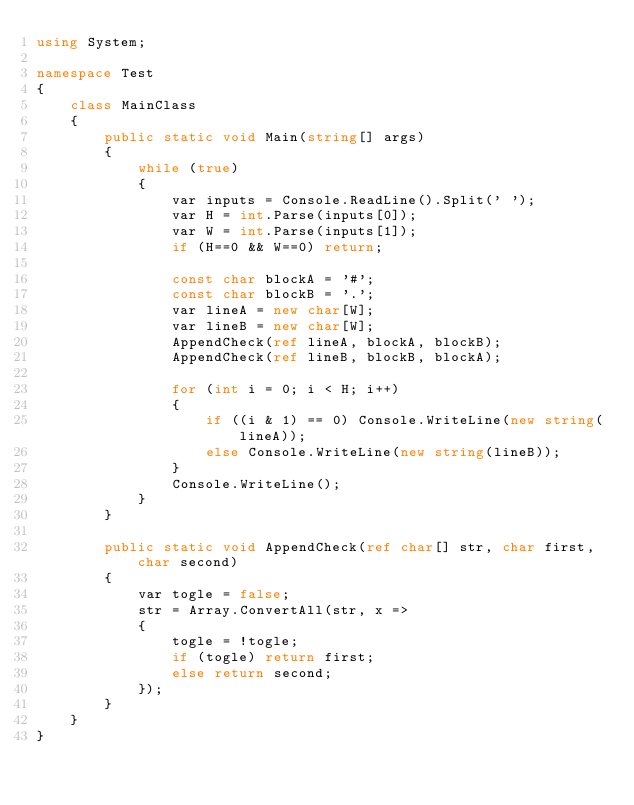<code> <loc_0><loc_0><loc_500><loc_500><_C#_>using System;

namespace Test
{
    class MainClass
    {
        public static void Main(string[] args)
        {
            while (true)
            {
                var inputs = Console.ReadLine().Split(' ');
                var H = int.Parse(inputs[0]);
                var W = int.Parse(inputs[1]);
                if (H==0 && W==0) return;

                const char blockA = '#';
                const char blockB = '.';
                var lineA = new char[W];
                var lineB = new char[W];
                AppendCheck(ref lineA, blockA, blockB);
                AppendCheck(ref lineB, blockB, blockA);

                for (int i = 0; i < H; i++)
                {
                    if ((i & 1) == 0) Console.WriteLine(new string(lineA));
                    else Console.WriteLine(new string(lineB));
                }
                Console.WriteLine();
            }
        }

        public static void AppendCheck(ref char[] str, char first, char second)
        {
            var togle = false;
            str = Array.ConvertAll(str, x =>
            {
                togle = !togle;
                if (togle) return first;
                else return second;
            });
        }
    }
}</code> 